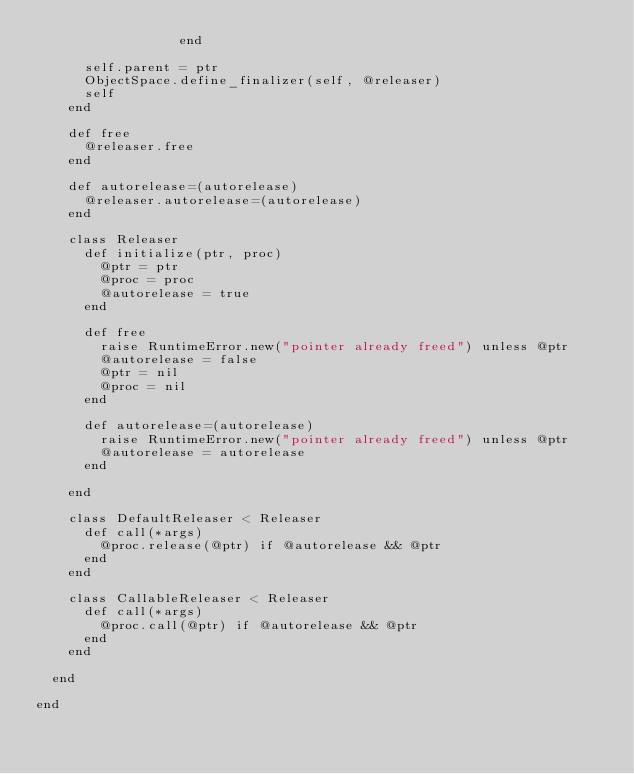<code> <loc_0><loc_0><loc_500><loc_500><_Ruby_>                  end

      self.parent = ptr
      ObjectSpace.define_finalizer(self, @releaser)
      self
    end

    def free
      @releaser.free
    end

    def autorelease=(autorelease)
      @releaser.autorelease=(autorelease)
    end

    class Releaser
      def initialize(ptr, proc)
        @ptr = ptr
        @proc = proc
        @autorelease = true
      end

      def free
        raise RuntimeError.new("pointer already freed") unless @ptr
        @autorelease = false
        @ptr = nil
        @proc = nil
      end
      
      def autorelease=(autorelease)
        raise RuntimeError.new("pointer already freed") unless @ptr
        @autorelease = autorelease
      end

    end

    class DefaultReleaser < Releaser
      def call(*args)
        @proc.release(@ptr) if @autorelease && @ptr
      end
    end

    class CallableReleaser < Releaser
      def call(*args)
        @proc.call(@ptr) if @autorelease && @ptr
      end
    end

  end

end
</code> 